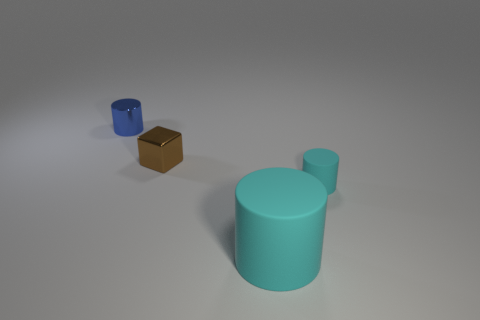What is the color of the block?
Keep it short and to the point. Brown. There is a cube that is made of the same material as the blue object; what color is it?
Ensure brevity in your answer.  Brown. What number of big cylinders have the same material as the tiny cyan cylinder?
Provide a short and direct response. 1. There is a block; what number of matte cylinders are to the right of it?
Your answer should be very brief. 2. Are the tiny cylinder in front of the blue shiny cylinder and the object that is behind the brown thing made of the same material?
Ensure brevity in your answer.  No. Are there more tiny things that are in front of the blue object than cyan things that are left of the tiny matte cylinder?
Make the answer very short. Yes. There is a cylinder that is the same color as the large rubber thing; what material is it?
Give a very brief answer. Rubber. Is there anything else that is the same shape as the tiny brown object?
Your response must be concise. No. The cylinder that is behind the big object and in front of the tiny blue metal cylinder is made of what material?
Make the answer very short. Rubber. Are the tiny cyan thing and the cylinder that is left of the brown thing made of the same material?
Your answer should be very brief. No. 